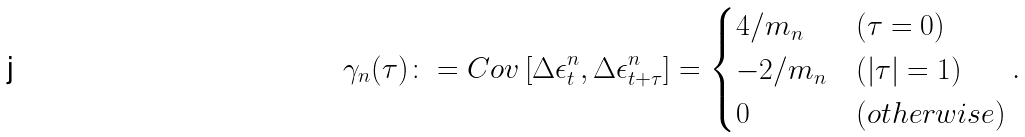<formula> <loc_0><loc_0><loc_500><loc_500>\gamma _ { n } ( \tau ) \colon = C o v \left [ \Delta \epsilon _ { t } ^ { n } , \Delta \epsilon _ { t + \tau } ^ { n } \right ] = \begin{cases} 4 / m _ { n } & ( \tau = 0 ) \\ - 2 / m _ { n } & ( | \tau | = 1 ) \\ 0 & ( o t h e r w i s e ) \end{cases} .</formula> 